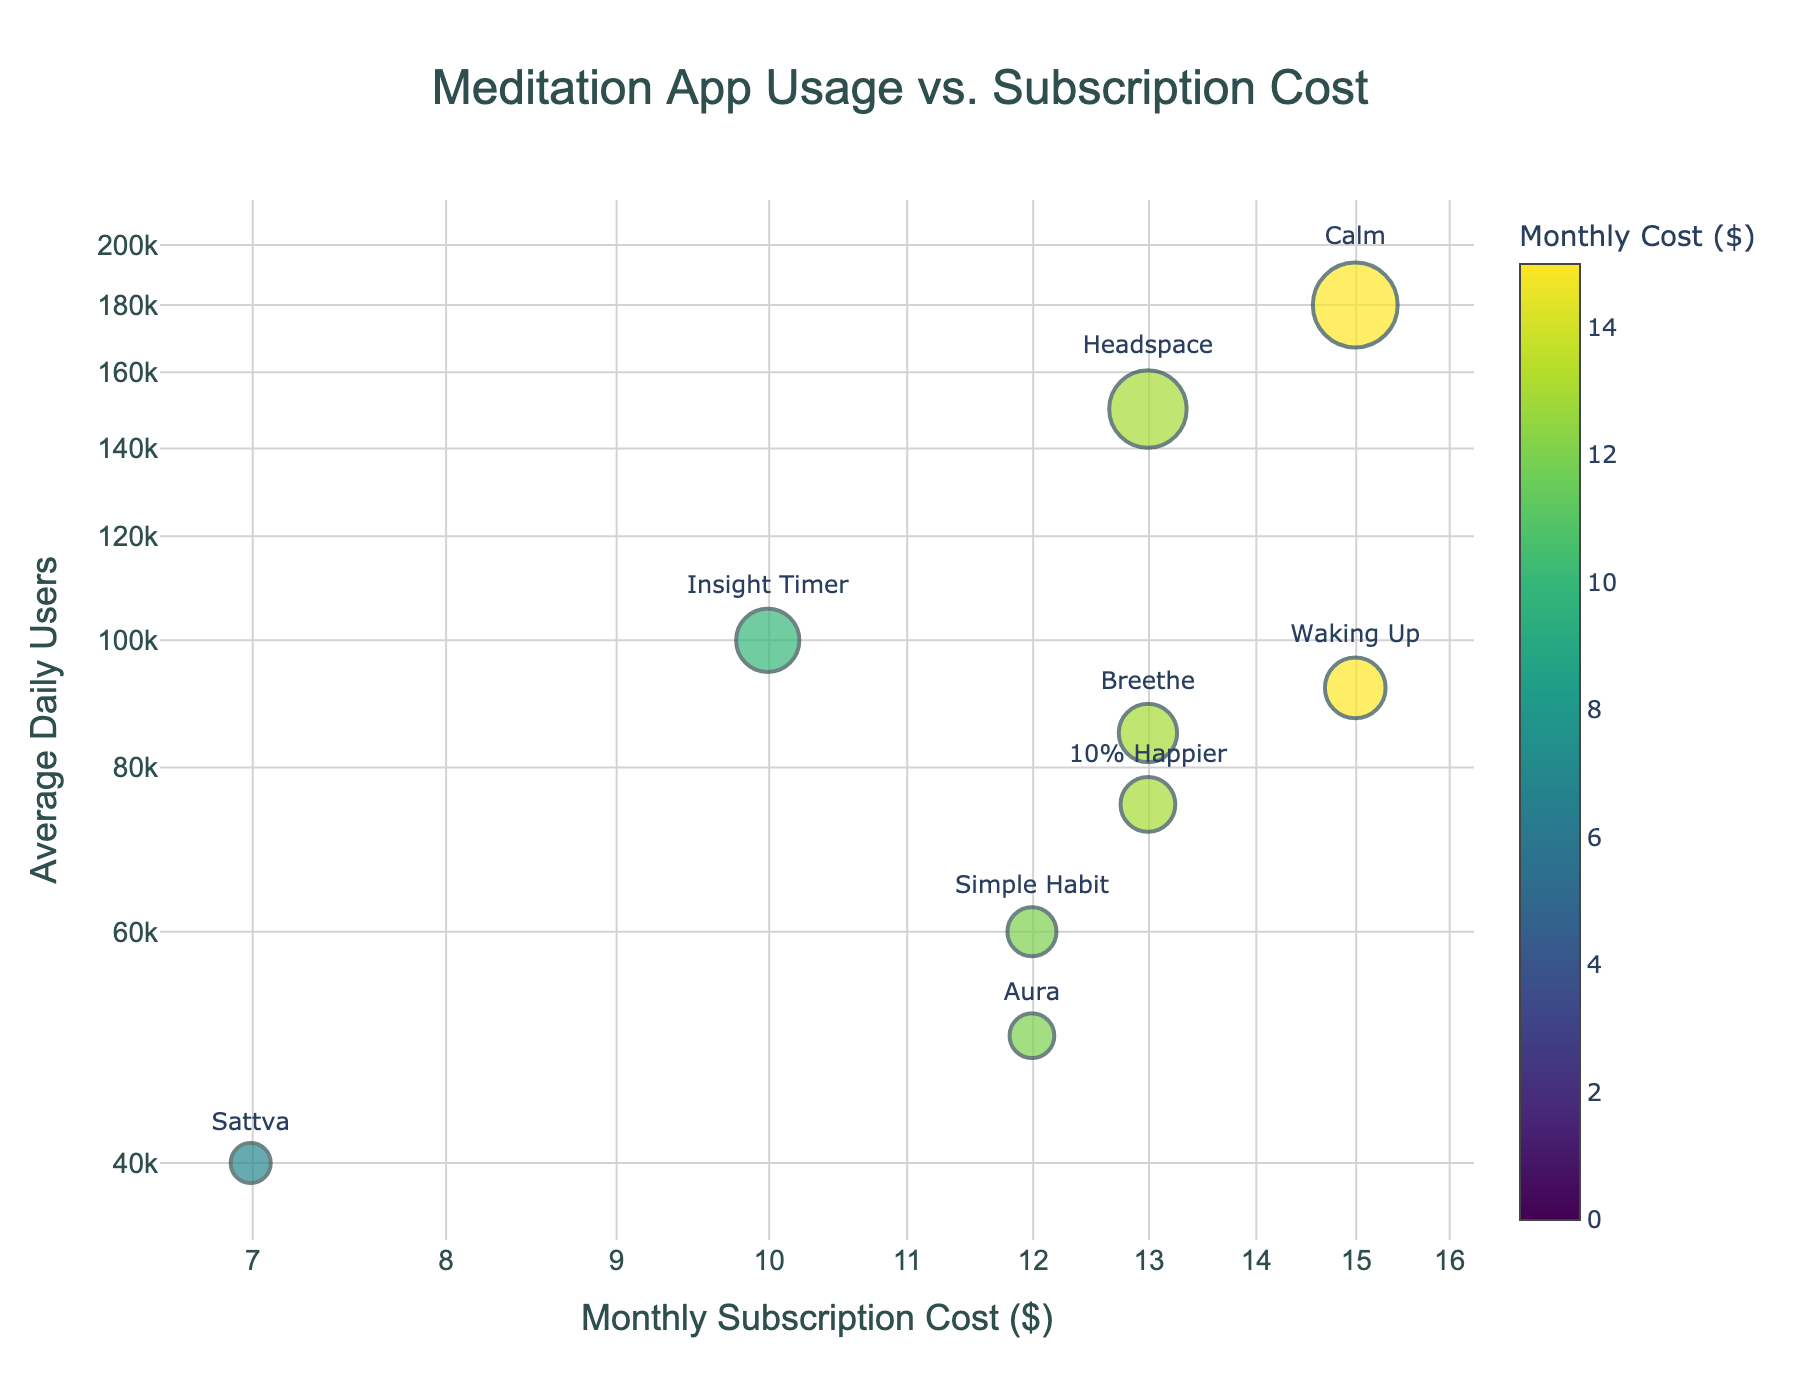How many meditation apps are shown in the scatter plot? By counting the number of unique data points (markers) labeled with app names, we can determine the number of apps shown.
Answer: 10 Which app has the highest average daily users? By looking at the y-axis (Average Daily Users) and identifying the marker at the highest point with the corresponding app name, we find the app with the highest number of daily users.
Answer: Calm What's the title of the scatter plot? The title is prominently displayed at the top of the figure.
Answer: Meditation App Usage vs. Subscription Cost Which app has the lowest monthly subscription cost and how many average daily users does it have? By identifying the marker at the lowest x-axis (Monthly Cost) value and reading the corresponding app name and y-axis value, we find both the app and the number of daily users.
Answer: Smiling Mind, 120000 How many apps have a monthly cost of $12.99? By examining the x-axis (Monthly Cost) and counting the number of markers at the $12.99 value, we find the number of such apps.
Answer: 3 Which app has the largest marker size and why? Marker size in the plot is proportional to the square root of average daily users. By identifying the largest marker and reading the associated app name, we can determine the app.
Answer: Calm, because it has the most daily users Do more expensive meditation apps tend to have more average daily users? By examining the scatter plot and observing the general trend between the x-axis (Monthly Cost) and the y-axis (Average Daily Users), we identify if there is a positive correlation.
Answer: No clear trend Which apps have a monthly cost of $14.99, and how do their average daily users compare? By identifying markers at the $14.99 value on the x-axis and reading the corresponding y-axis values and app names, we compare the user numbers.
Answer: Calm (180,000), Waking Up (92,000) What is the total number of average daily users for all apps? Sum the y-axis values (average daily users) for all apps to get the total number.
Answer: 920,000 Which app has the smallest marker size and what is its monthly cost? Marker size is proportional to the square root of average daily users. Identifying the smallest marker and the corresponding app and cost provides the answer.
Answer: Sattva, $6.99 